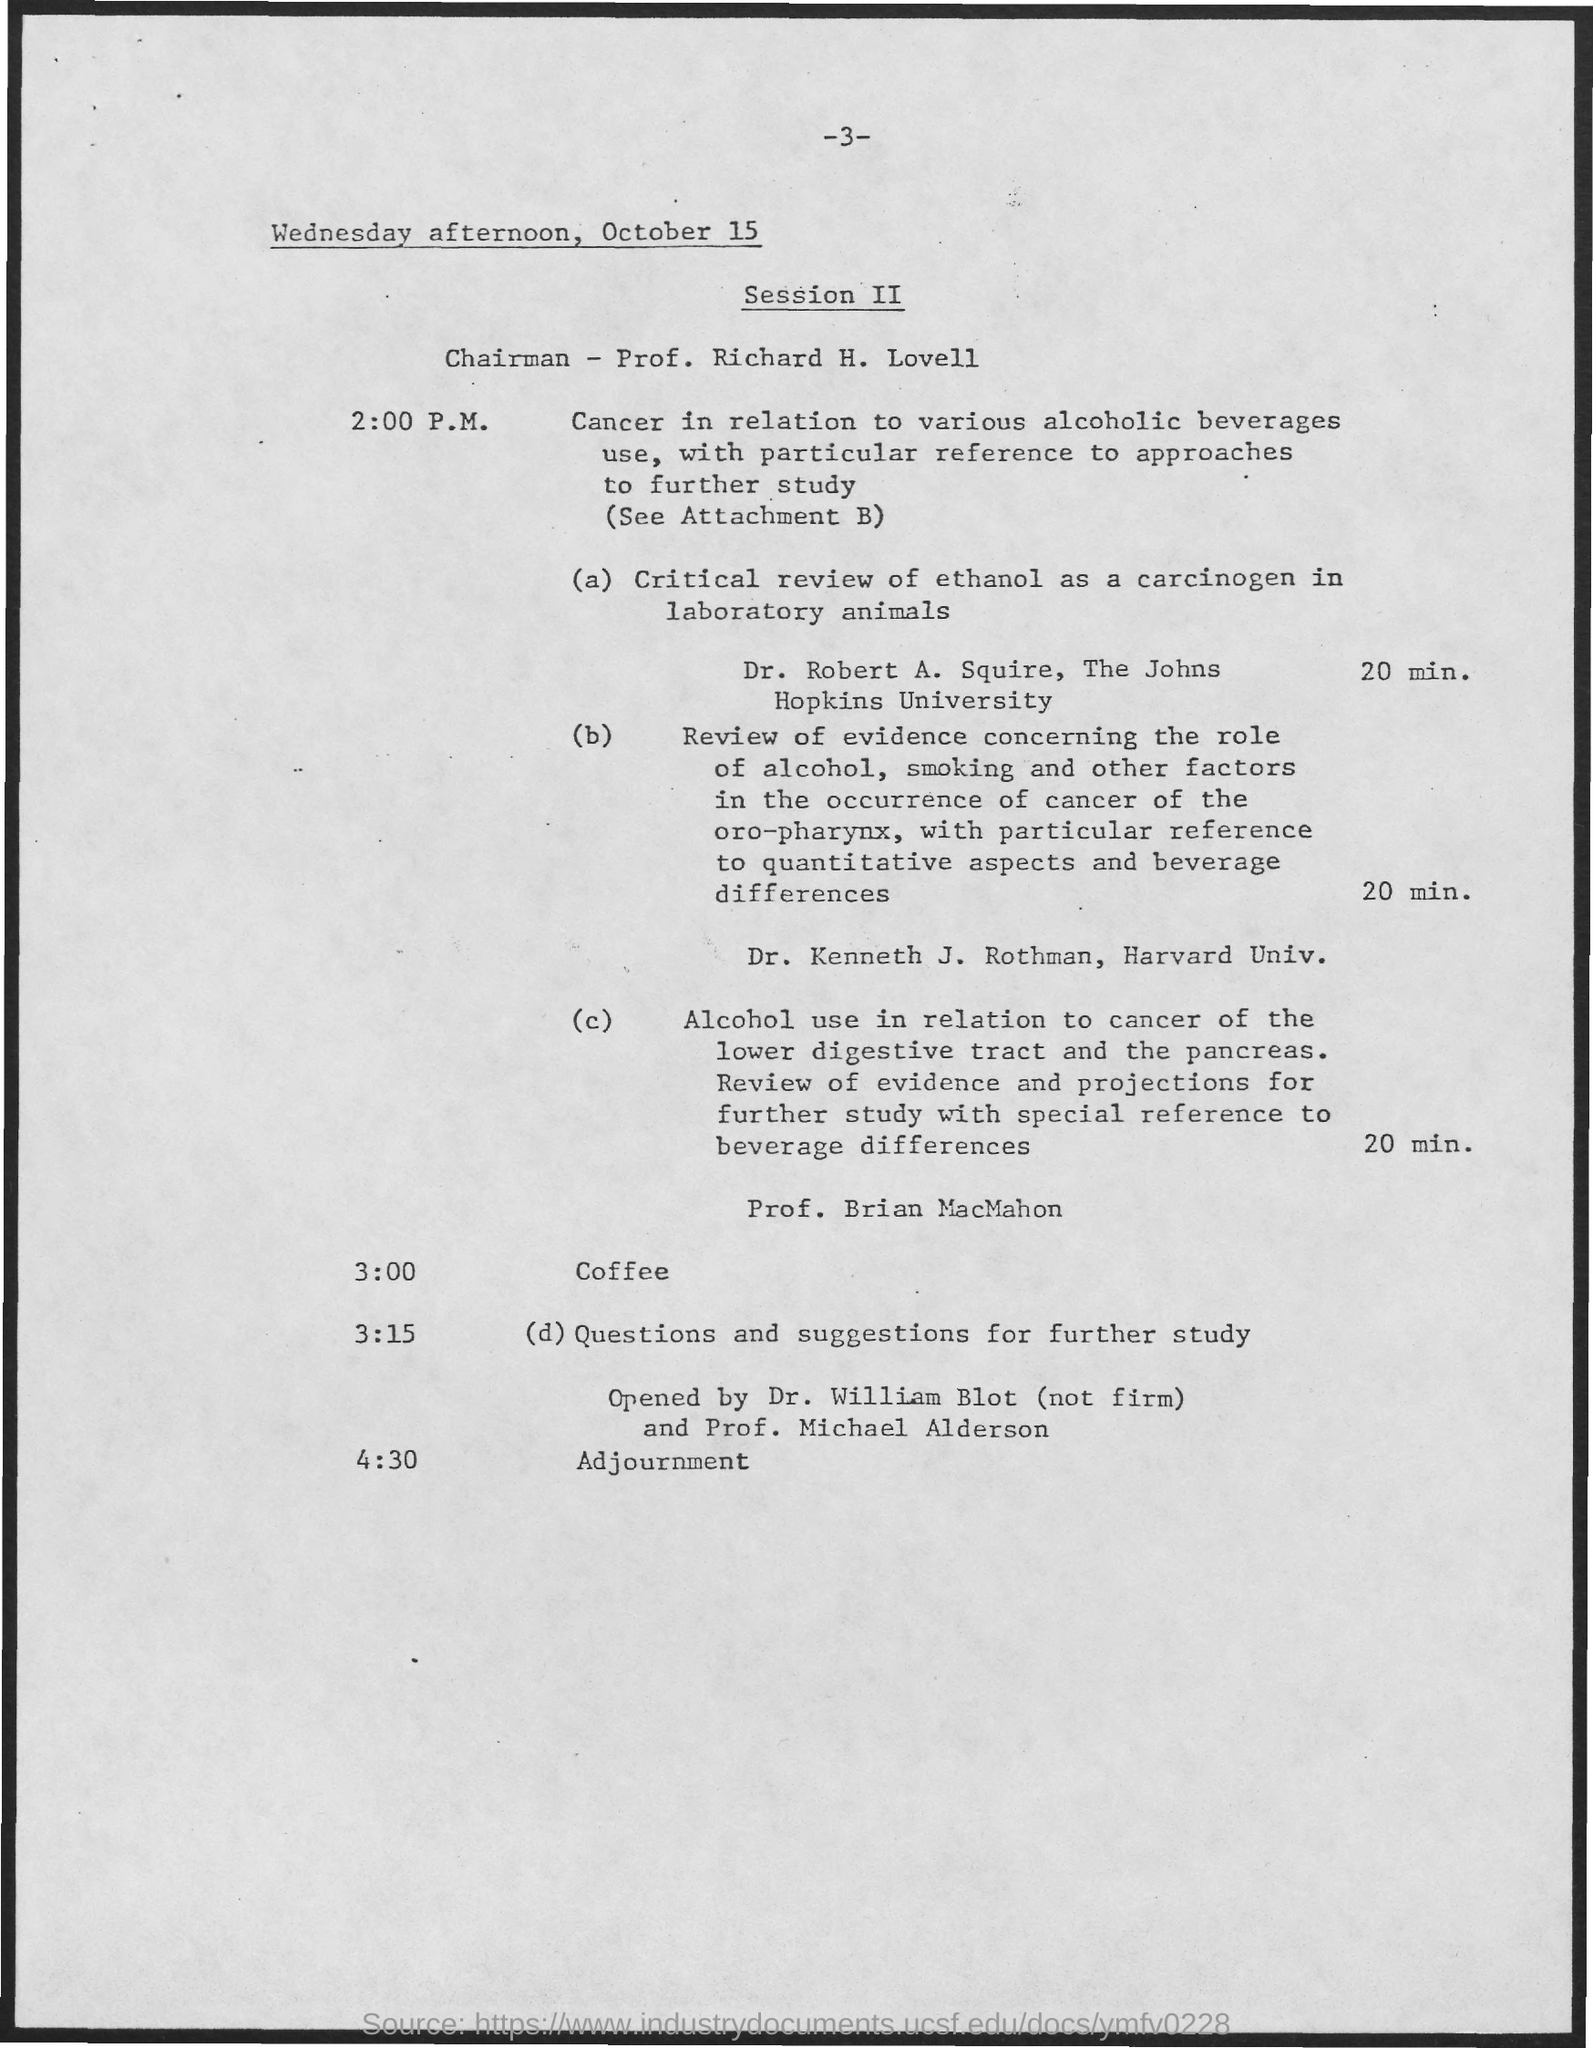Give some essential details in this illustration. At 4:30, an adjournment is scheduled to take place. The Chairman of Session II is Prof. Richard H. Lovell. At 3:00 PM, coffee is scheduled. 